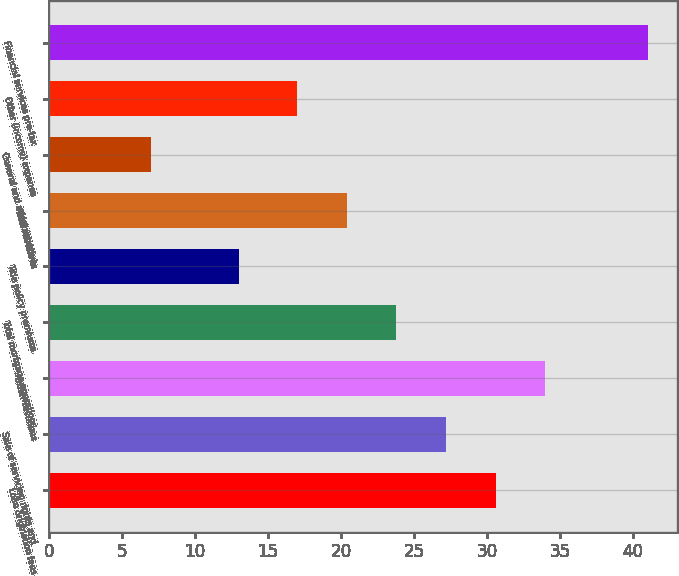Convert chart. <chart><loc_0><loc_0><loc_500><loc_500><bar_chart><fcel>Loan origination fees<fcel>Sale of servicing rights and<fcel>Other revenues<fcel>Total mortgage operations<fcel>Title policy premiums<fcel>Total revenues<fcel>General and administrative<fcel>Other (income) expense<fcel>Financial services pre-tax<nl><fcel>30.6<fcel>27.2<fcel>34<fcel>23.8<fcel>13<fcel>20.4<fcel>7<fcel>17<fcel>41<nl></chart> 